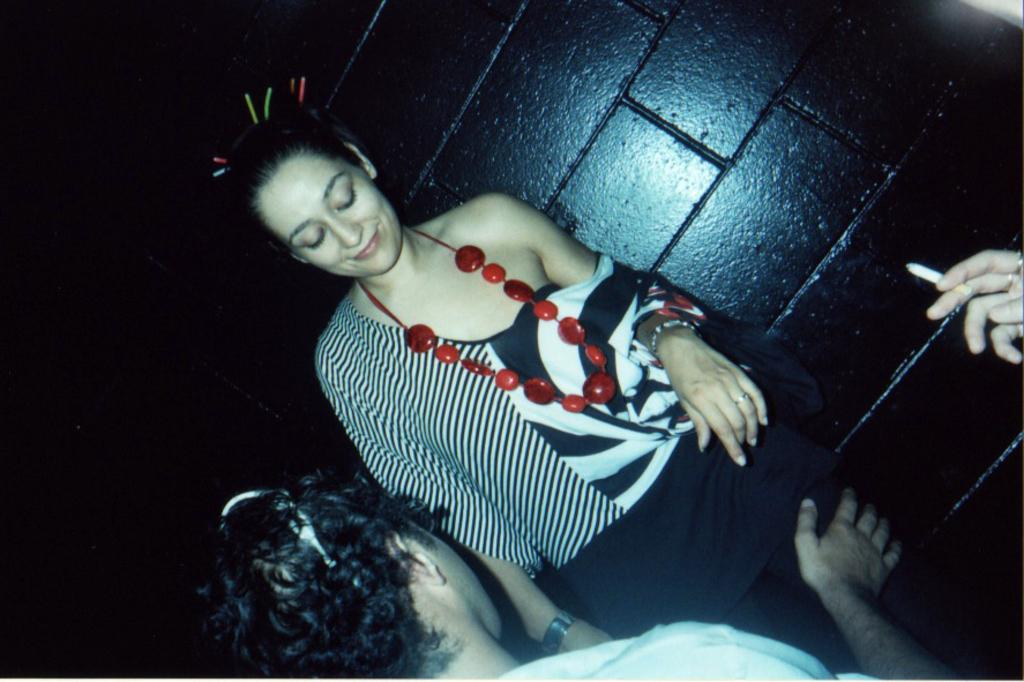How many people are in the image? There are two people in the image. Can you describe any objects or actions involving the people? There is a hand holding a cigarette in the image. What is the background of the image? There is a black wall behind the people. What is the name of the trail visible in the image? There is no trail visible in the image; it features two people and a hand holding a cigarette in front of a black wall. 